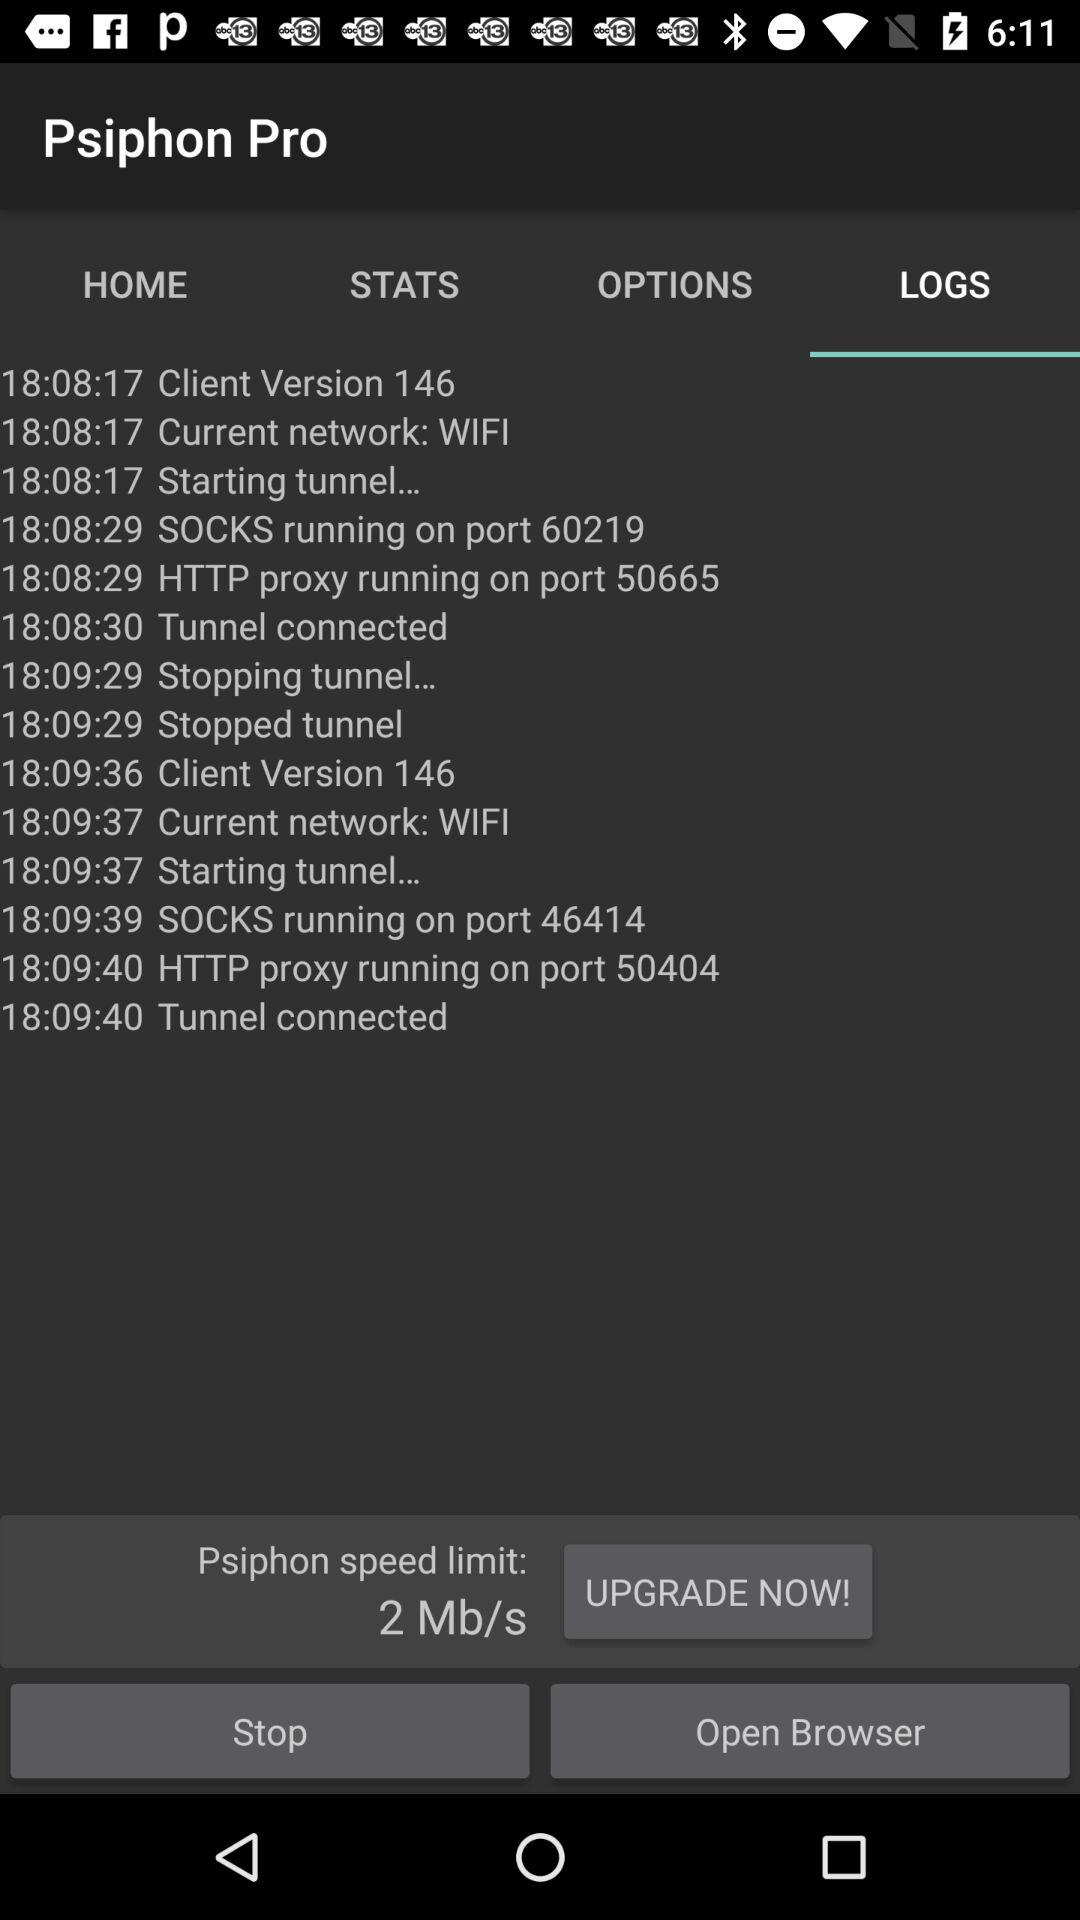How many socks ports are running?
Answer the question using a single word or phrase. 2 